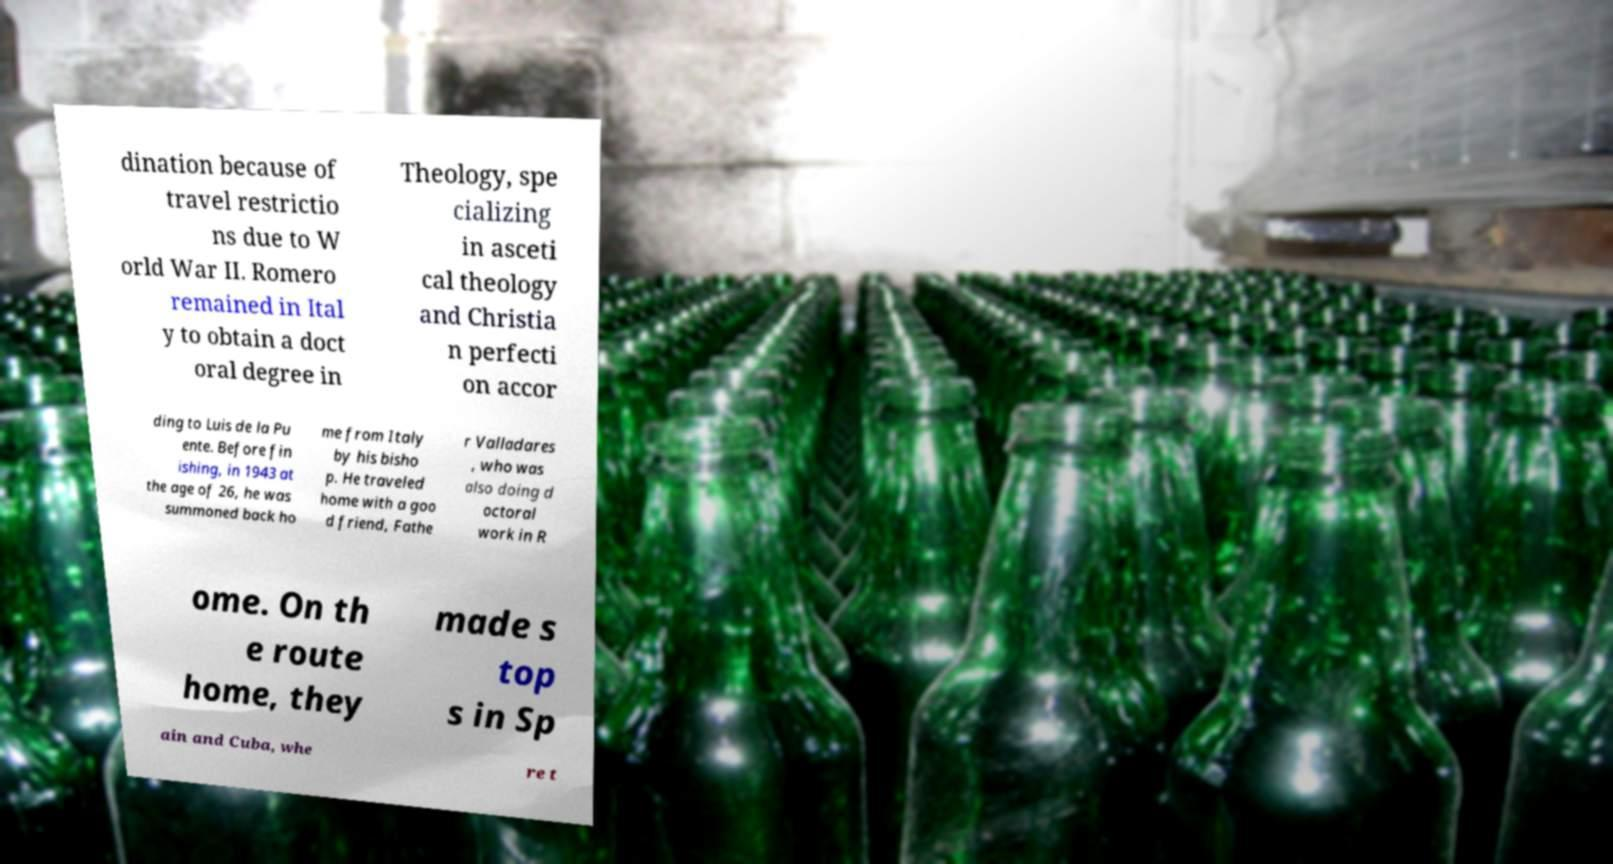Could you extract and type out the text from this image? dination because of travel restrictio ns due to W orld War II. Romero remained in Ital y to obtain a doct oral degree in Theology, spe cializing in asceti cal theology and Christia n perfecti on accor ding to Luis de la Pu ente. Before fin ishing, in 1943 at the age of 26, he was summoned back ho me from Italy by his bisho p. He traveled home with a goo d friend, Fathe r Valladares , who was also doing d octoral work in R ome. On th e route home, they made s top s in Sp ain and Cuba, whe re t 